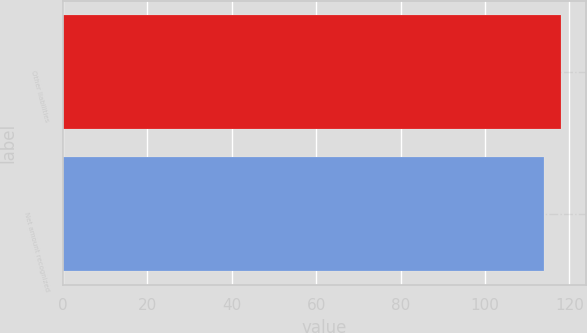Convert chart. <chart><loc_0><loc_0><loc_500><loc_500><bar_chart><fcel>Other liabilities<fcel>Net amount recognized<nl><fcel>118<fcel>114<nl></chart> 